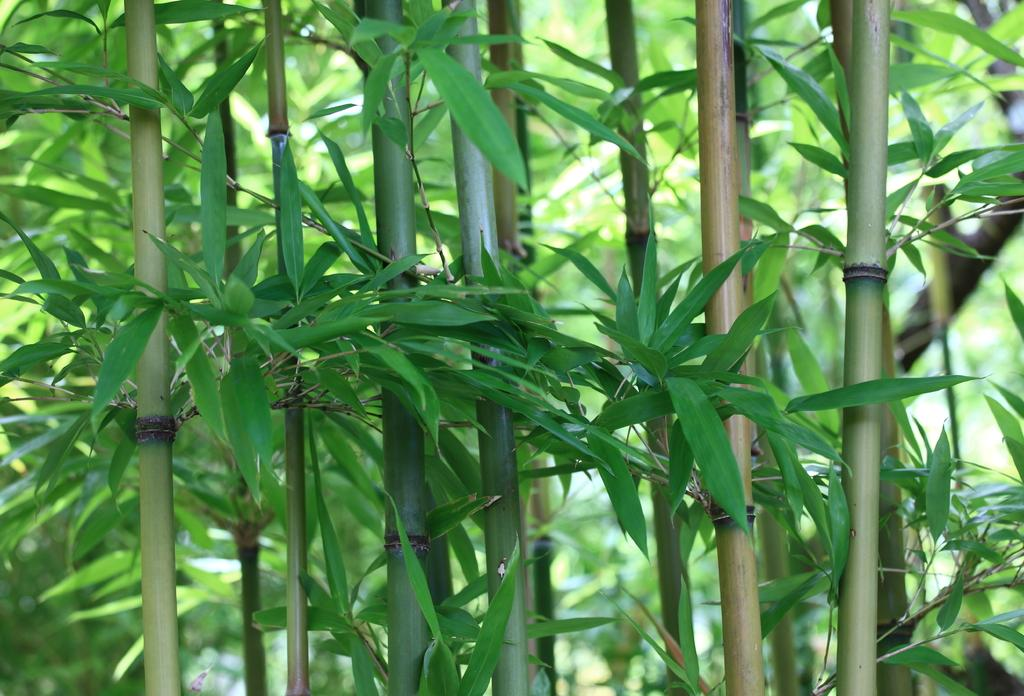What type of vegetation can be seen in the image? There are leaves and branches in the image. Can you describe the branches in the image? The branches are likely part of a tree or plant, and they are connected to the leaves. Did the earthquake cause the leaves to fall off the tree in the image? There is no indication of an earthquake or any fallen leaves in the image, so we cannot determine if an earthquake caused the leaves to fall. 